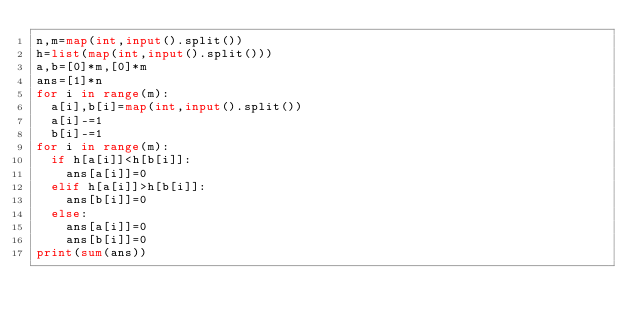<code> <loc_0><loc_0><loc_500><loc_500><_Python_>n,m=map(int,input().split())
h=list(map(int,input().split()))
a,b=[0]*m,[0]*m
ans=[1]*n
for i in range(m):
  a[i],b[i]=map(int,input().split())
  a[i]-=1
  b[i]-=1
for i in range(m):
  if h[a[i]]<h[b[i]]:
    ans[a[i]]=0
  elif h[a[i]]>h[b[i]]:
    ans[b[i]]=0
  else:
    ans[a[i]]=0
    ans[b[i]]=0
print(sum(ans))</code> 